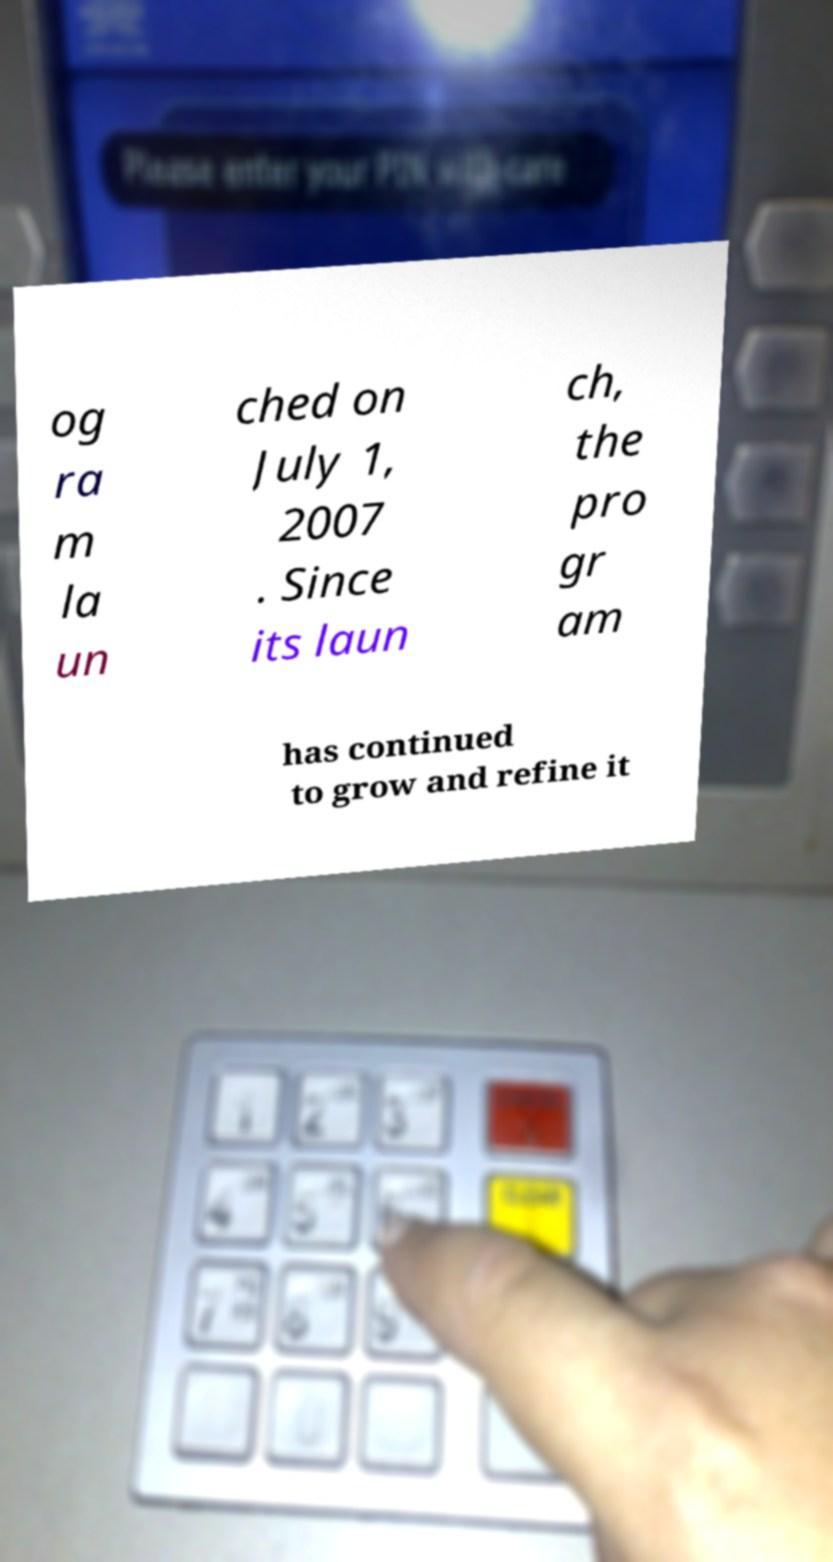What messages or text are displayed in this image? I need them in a readable, typed format. og ra m la un ched on July 1, 2007 . Since its laun ch, the pro gr am has continued to grow and refine it 